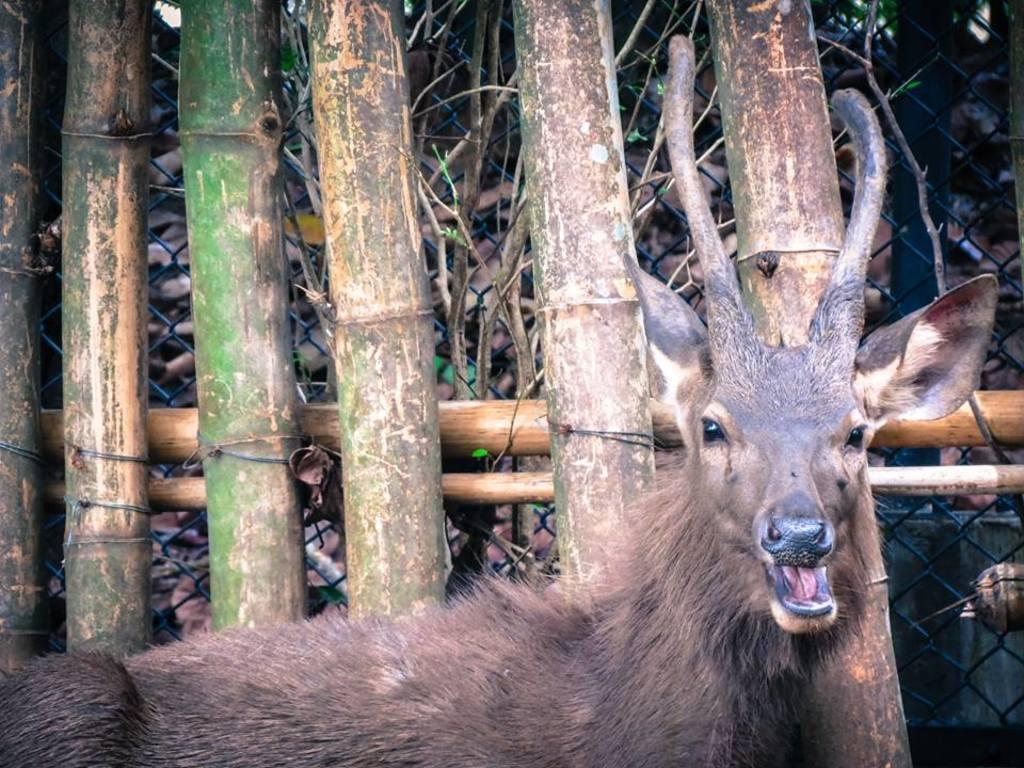What type of animal is present in the image? There is an animal in the image, but its specific type cannot be determined from the provided facts. What kind of structures can be seen in the image? There are wooden poles and a metal fence visible in the image. What type of vegetation is present in the image? There are trees in the image. What type of truck can be seen participating in the feast in the image? There is no truck or feast present in the image. How quiet is the animal in the image? The provided facts do not give any information about the animal's behavior or noise level, so it cannot be determined from the image. 